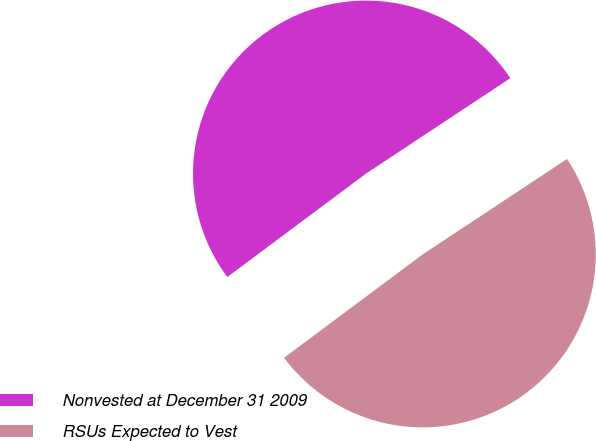Convert chart to OTSL. <chart><loc_0><loc_0><loc_500><loc_500><pie_chart><fcel>Nonvested at December 31 2009<fcel>RSUs Expected to Vest<nl><fcel>50.9%<fcel>49.1%<nl></chart> 